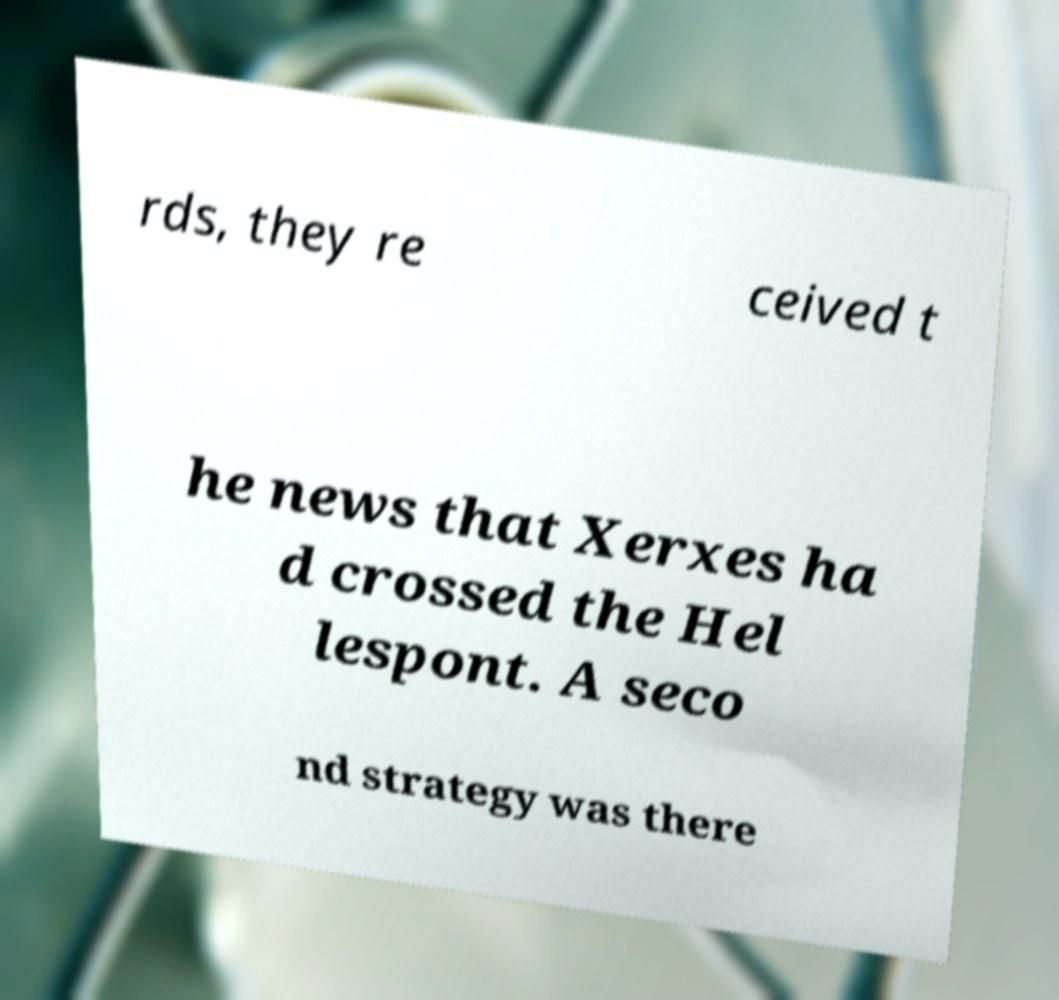I need the written content from this picture converted into text. Can you do that? rds, they re ceived t he news that Xerxes ha d crossed the Hel lespont. A seco nd strategy was there 